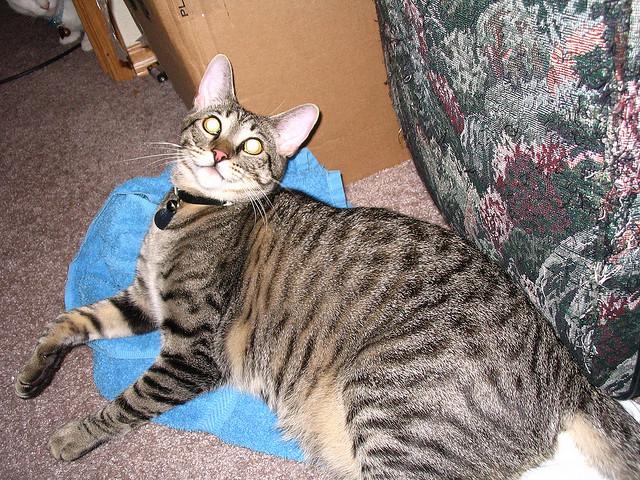Is the cat alive?
Short answer required. Yes. How many red hearts in the photo?
Quick response, please. 0. What is the name of this cat?
Keep it brief. Stripes. Is this cat starving?
Give a very brief answer. No. 